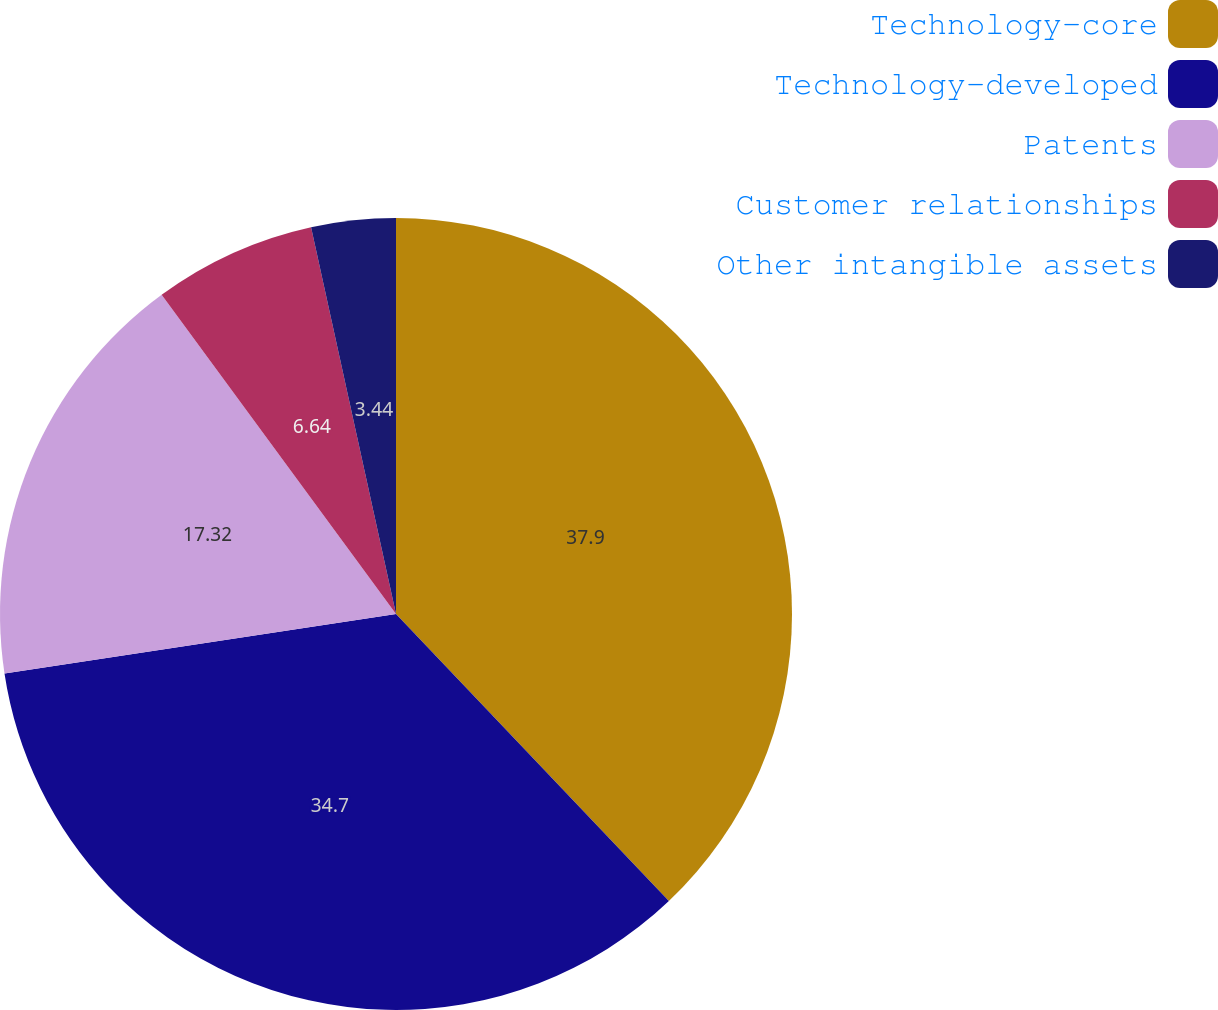Convert chart. <chart><loc_0><loc_0><loc_500><loc_500><pie_chart><fcel>Technology-core<fcel>Technology-developed<fcel>Patents<fcel>Customer relationships<fcel>Other intangible assets<nl><fcel>37.9%<fcel>34.7%<fcel>17.32%<fcel>6.64%<fcel>3.44%<nl></chart> 